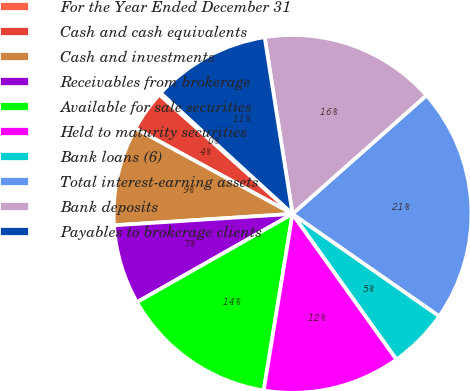Convert chart. <chart><loc_0><loc_0><loc_500><loc_500><pie_chart><fcel>For the Year Ended December 31<fcel>Cash and cash equivalents<fcel>Cash and investments<fcel>Receivables from brokerage<fcel>Available for sale securities<fcel>Held to maturity securities<fcel>Bank loans (6)<fcel>Total interest-earning assets<fcel>Bank deposits<fcel>Payables to brokerage clients<nl><fcel>0.19%<fcel>3.69%<fcel>8.95%<fcel>7.2%<fcel>14.21%<fcel>12.45%<fcel>5.44%<fcel>21.22%<fcel>15.96%<fcel>10.7%<nl></chart> 